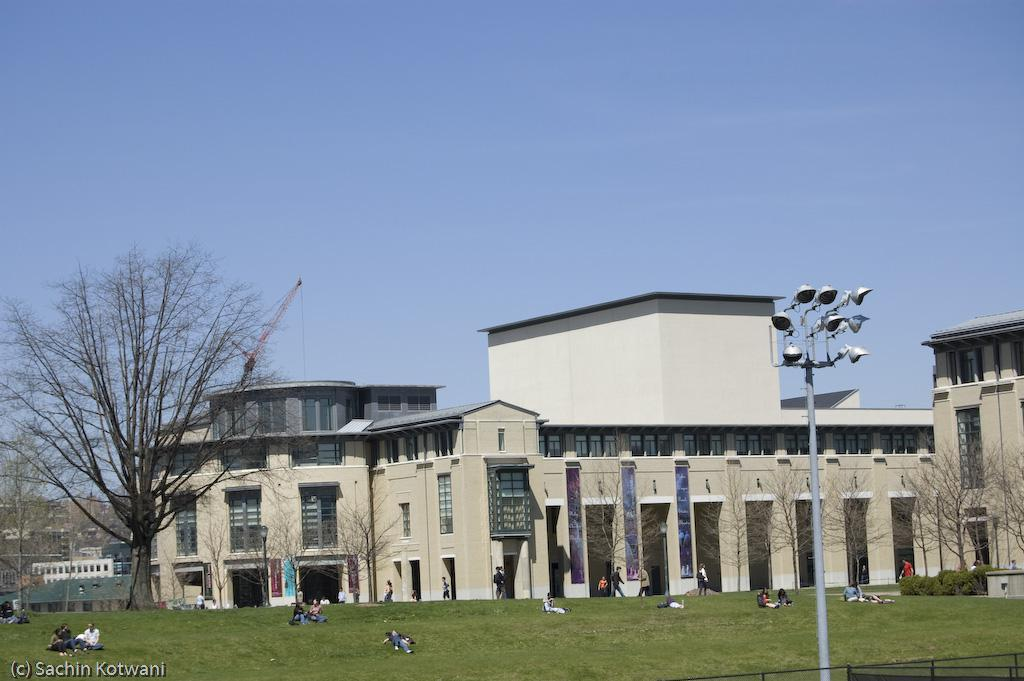What are the people in the image doing? The people in the image are sitting on the grass. What can be seen in the distance behind the people? There are buildings and trees visible in the background of the image. What color is the orange that the people are holding in the image? There is no orange present in the image; the people are sitting on the grass. 